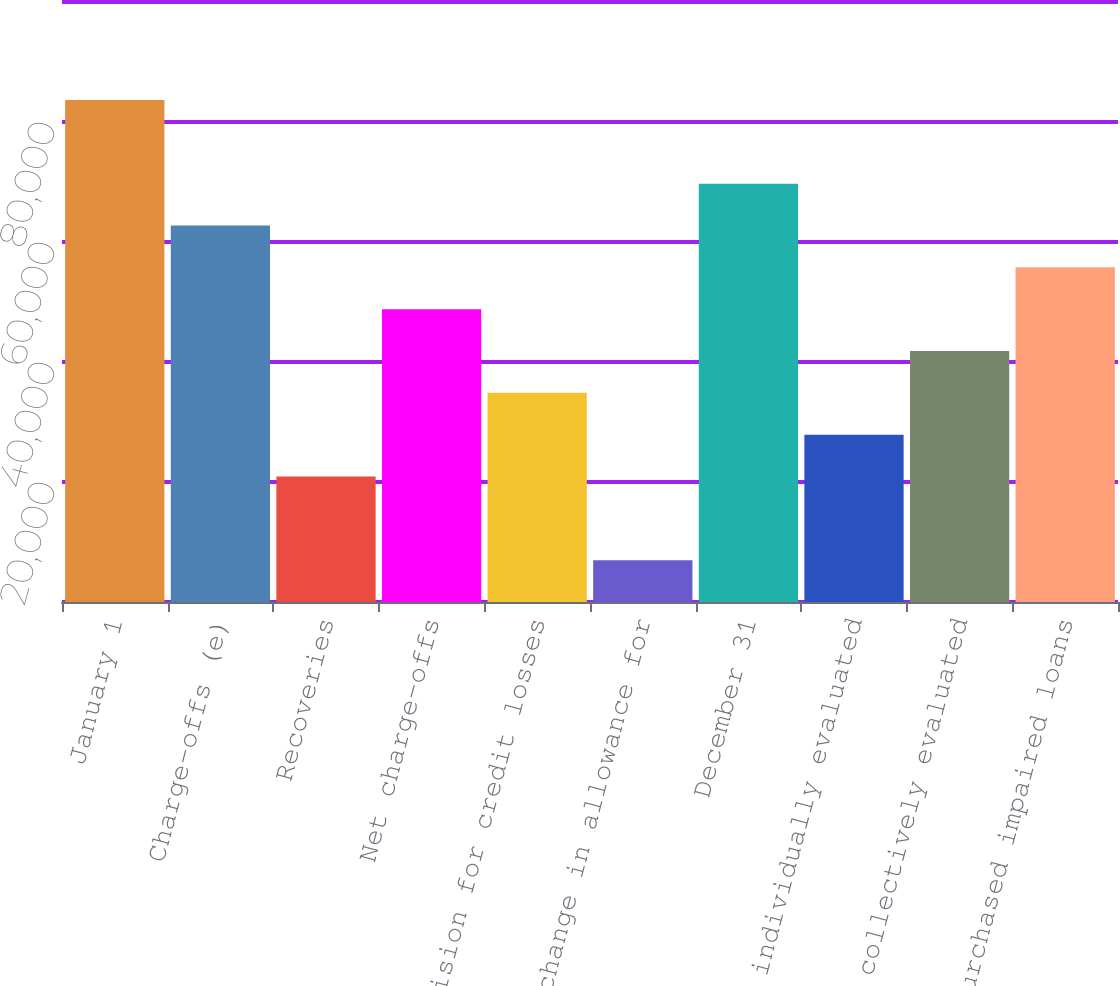<chart> <loc_0><loc_0><loc_500><loc_500><bar_chart><fcel>January 1<fcel>Charge-offs (e)<fcel>Recoveries<fcel>Net charge-offs<fcel>Provision for credit losses<fcel>Net change in allowance for<fcel>December 31<fcel>TDRs individually evaluated<fcel>Loans collectively evaluated<fcel>Purchased impaired loans<nl><fcel>83668.3<fcel>62751.9<fcel>20919<fcel>48807.6<fcel>34863.3<fcel>6974.77<fcel>69724<fcel>27891.2<fcel>41835.5<fcel>55779.8<nl></chart> 